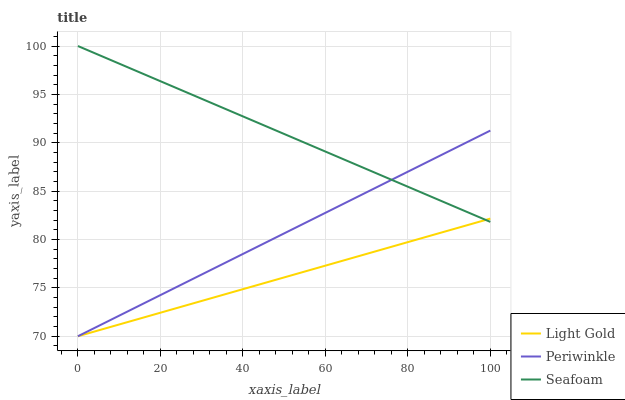Does Light Gold have the minimum area under the curve?
Answer yes or no. Yes. Does Seafoam have the maximum area under the curve?
Answer yes or no. Yes. Does Seafoam have the minimum area under the curve?
Answer yes or no. No. Does Light Gold have the maximum area under the curve?
Answer yes or no. No. Is Light Gold the smoothest?
Answer yes or no. Yes. Is Periwinkle the roughest?
Answer yes or no. Yes. Is Seafoam the smoothest?
Answer yes or no. No. Is Seafoam the roughest?
Answer yes or no. No. Does Seafoam have the lowest value?
Answer yes or no. No. Does Light Gold have the highest value?
Answer yes or no. No. 